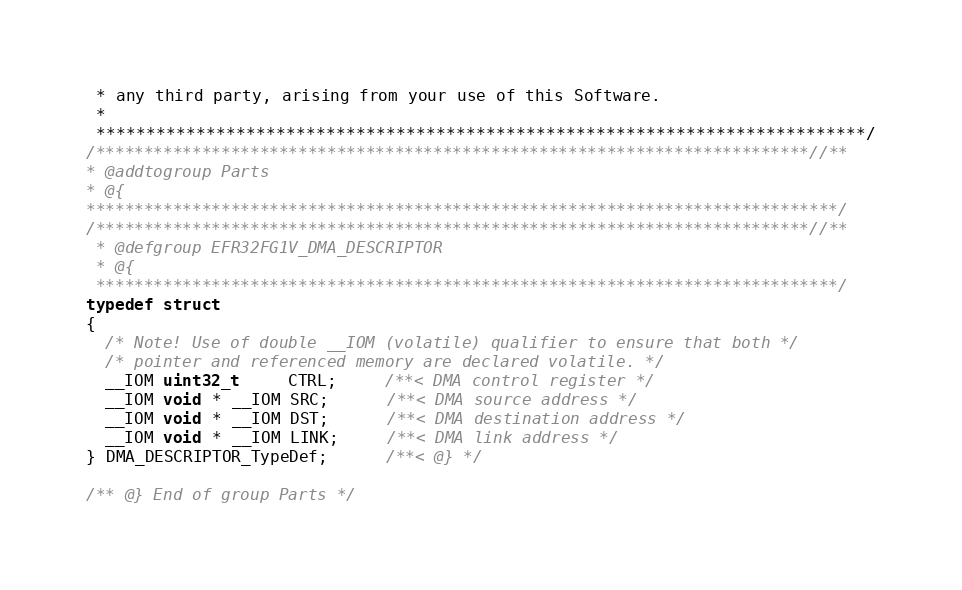<code> <loc_0><loc_0><loc_500><loc_500><_C_> * any third party, arising from your use of this Software.
 *
 *****************************************************************************/
/**************************************************************************//**
* @addtogroup Parts
* @{
******************************************************************************/
/**************************************************************************//**
 * @defgroup EFR32FG1V_DMA_DESCRIPTOR
 * @{
 *****************************************************************************/
typedef struct
{
  /* Note! Use of double __IOM (volatile) qualifier to ensure that both */
  /* pointer and referenced memory are declared volatile. */
  __IOM uint32_t     CTRL;     /**< DMA control register */
  __IOM void * __IOM SRC;      /**< DMA source address */
  __IOM void * __IOM DST;      /**< DMA destination address */
  __IOM void * __IOM LINK;     /**< DMA link address */
} DMA_DESCRIPTOR_TypeDef;      /**< @} */

/** @} End of group Parts */


</code> 